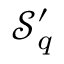Convert formula to latex. <formula><loc_0><loc_0><loc_500><loc_500>\mathcal { S } _ { q } ^ { \prime }</formula> 